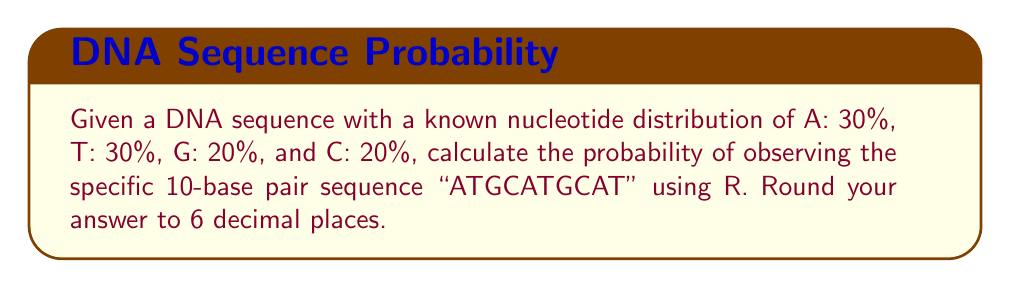Teach me how to tackle this problem. To solve this problem, we'll follow these steps:

1) First, we need to understand that each nucleotide in the sequence is an independent event. The probability of the entire sequence is the product of the probabilities of each individual nucleotide.

2) Let's assign probabilities to each nucleotide:
   $P(A) = 0.30$
   $P(T) = 0.30$
   $P(G) = 0.20$
   $P(C) = 0.20$

3) Now, let's calculate the probability of the sequence "ATGCATGCAT":

   $$P(\text{ATGCATGCAT}) = P(A) \times P(T) \times P(G) \times P(C) \times P(A) \times P(T) \times P(G) \times P(C) \times P(A) \times P(T)$$

4) Substituting the probabilities:

   $$P(\text{ATGCATGCAT}) = 0.30 \times 0.30 \times 0.20 \times 0.20 \times 0.30 \times 0.30 \times 0.20 \times 0.20 \times 0.30 \times 0.30$$

5) In R, we can calculate this as follows:

   ```r
   prob <- 0.30^4 * 0.20^3 * 0.30^3
   round(prob, 6)
   ```

6) This gives us the final probability, rounded to 6 decimal places.
Answer: $1.944 \times 10^{-5}$ 